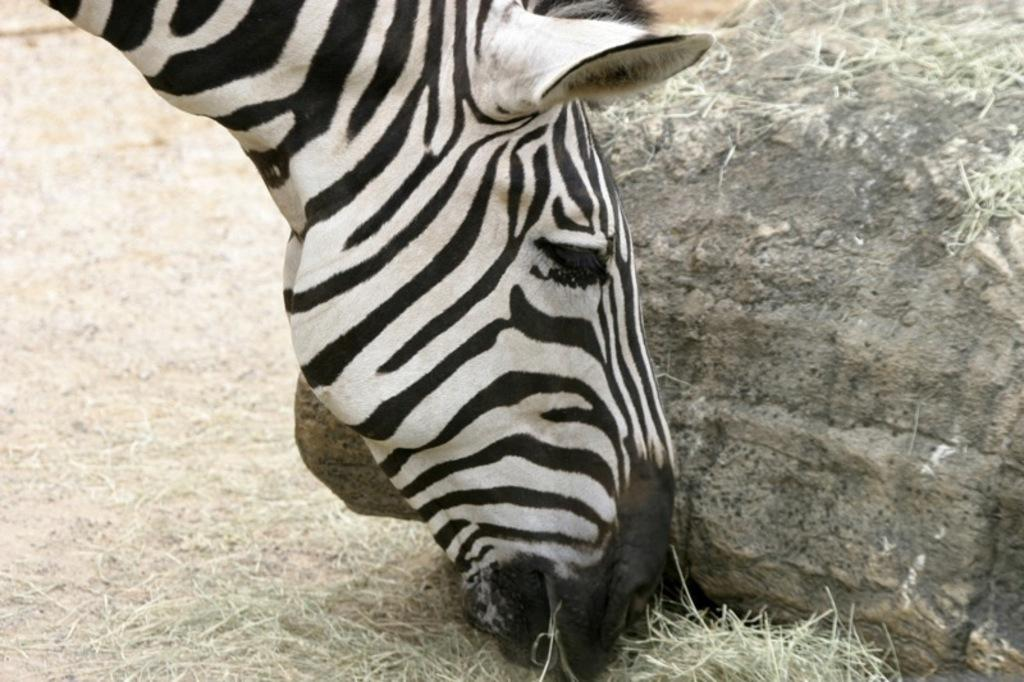What type of animal can be seen in the image? There is an animal in the image, but the specific type cannot be determined from the provided facts. What type of vegetation is visible in the image? There is grass visible in the image. What object can be seen at the right side of the image? There is a rock at the right side of the image. What is the animal's reaction to the patch of anger in the image? There is no patch of anger present in the image, so it is not possible to determine the animal's reaction to it. 